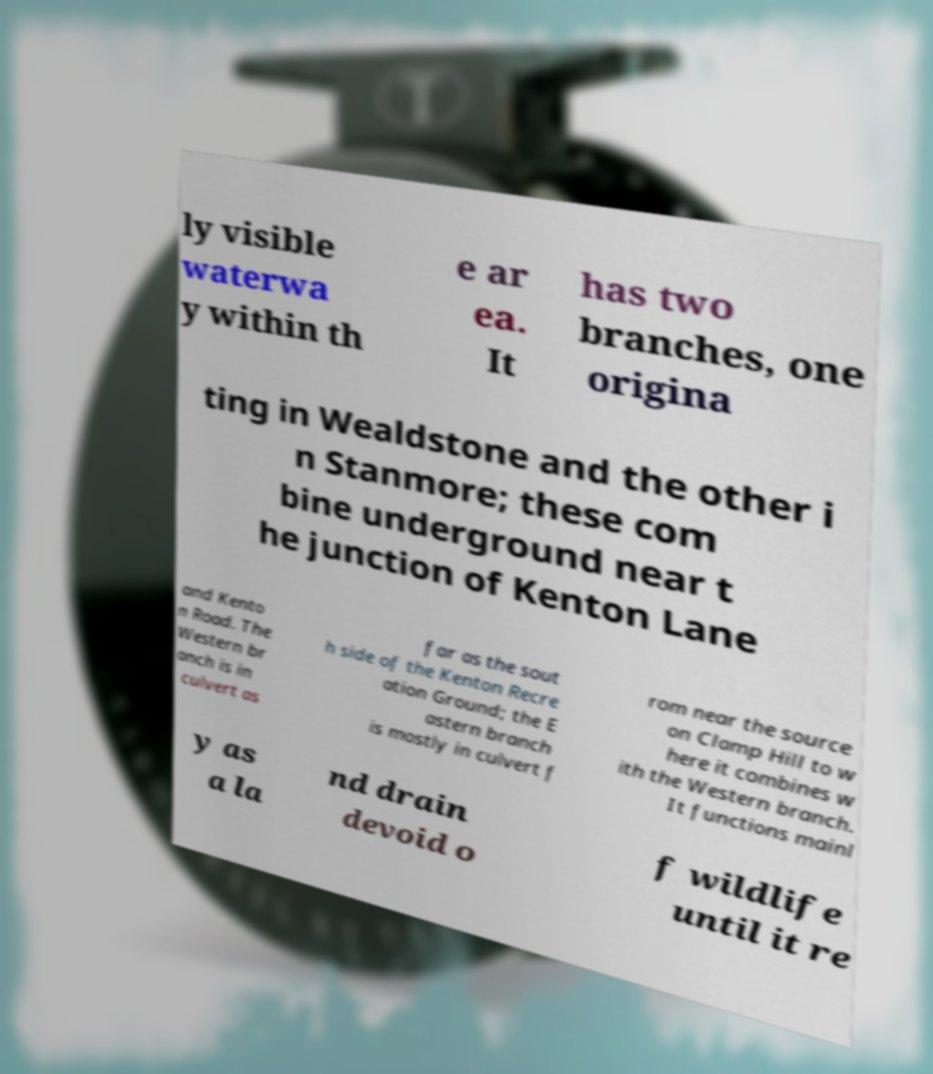Can you read and provide the text displayed in the image?This photo seems to have some interesting text. Can you extract and type it out for me? ly visible waterwa y within th e ar ea. It has two branches, one origina ting in Wealdstone and the other i n Stanmore; these com bine underground near t he junction of Kenton Lane and Kento n Road. The Western br anch is in culvert as far as the sout h side of the Kenton Recre ation Ground; the E astern branch is mostly in culvert f rom near the source on Clamp Hill to w here it combines w ith the Western branch. It functions mainl y as a la nd drain devoid o f wildlife until it re 